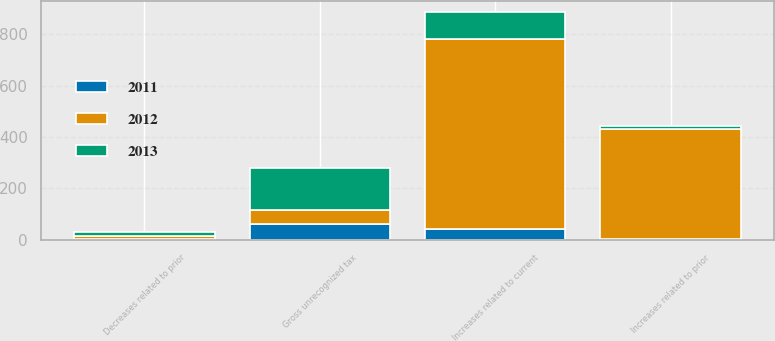<chart> <loc_0><loc_0><loc_500><loc_500><stacked_bar_chart><ecel><fcel>Gross unrecognized tax<fcel>Increases related to prior<fcel>Decreases related to prior<fcel>Increases related to current<nl><fcel>2012<fcel>52.5<fcel>425<fcel>13<fcel>740<nl><fcel>2013<fcel>164<fcel>13<fcel>16<fcel>104<nl><fcel>2011<fcel>63<fcel>5<fcel>2<fcel>42<nl></chart> 